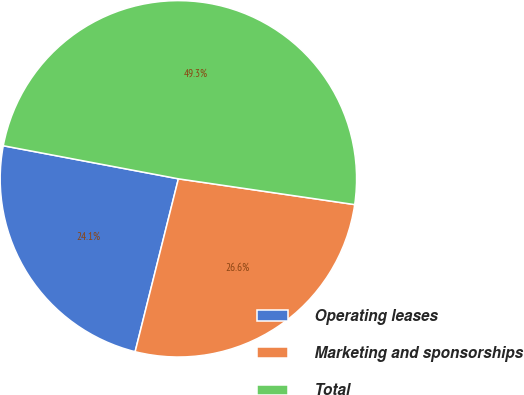Convert chart to OTSL. <chart><loc_0><loc_0><loc_500><loc_500><pie_chart><fcel>Operating leases<fcel>Marketing and sponsorships<fcel>Total<nl><fcel>24.07%<fcel>26.59%<fcel>49.34%<nl></chart> 